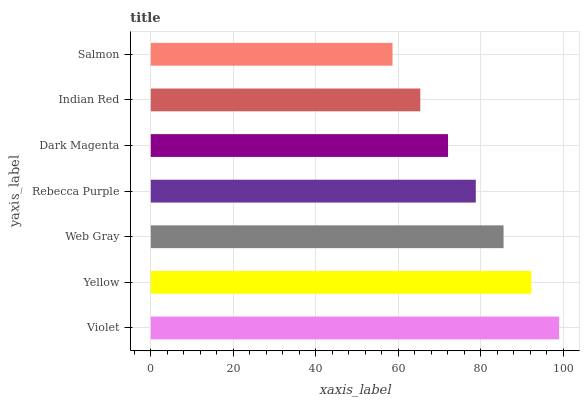Is Salmon the minimum?
Answer yes or no. Yes. Is Violet the maximum?
Answer yes or no. Yes. Is Yellow the minimum?
Answer yes or no. No. Is Yellow the maximum?
Answer yes or no. No. Is Violet greater than Yellow?
Answer yes or no. Yes. Is Yellow less than Violet?
Answer yes or no. Yes. Is Yellow greater than Violet?
Answer yes or no. No. Is Violet less than Yellow?
Answer yes or no. No. Is Rebecca Purple the high median?
Answer yes or no. Yes. Is Rebecca Purple the low median?
Answer yes or no. Yes. Is Indian Red the high median?
Answer yes or no. No. Is Yellow the low median?
Answer yes or no. No. 